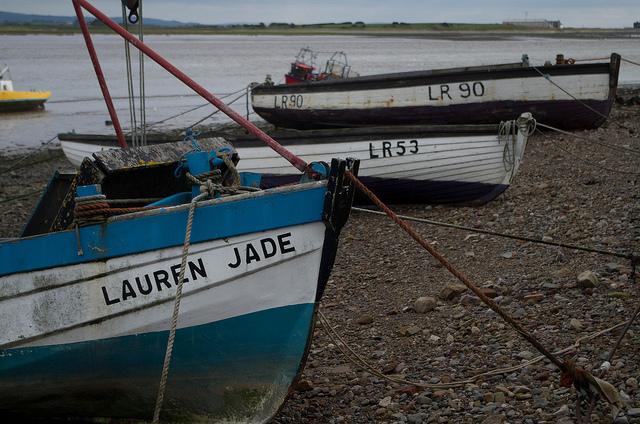What is written on the far left boat?
Give a very brief answer. Lauren jade. What is the name of the boat?
Be succinct. Lauren jade. Can this fly?
Short answer required. No. What type of boat is the larger one?
Write a very short answer. Sailboat. Where are the boats sitting?
Answer briefly. Shore. What are the words on the boat?
Be succinct. Lauren jade. What is the shore made of?
Write a very short answer. Rocks. 